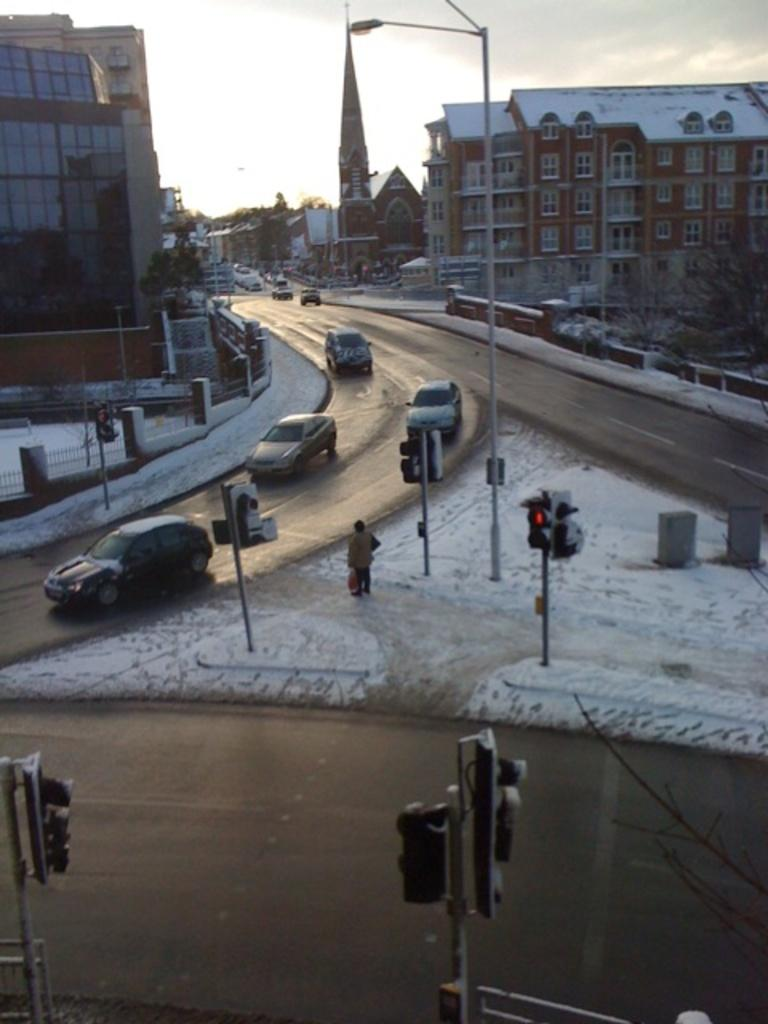What type of signal device is present in the image? There are traffic lights in the image. What is happening on the road in the image? There are vehicles on the road in the image. Who or what is located in the middle of the image? There is a person in the middle of the image. What can be seen in the distance behind the person? There are trees and buildings in the background of the image. What type of silk material is draped over the person in the image? There is no silk material present in the image. How many friends are visible with the person in the image? There are no friends visible with the person in the image. 